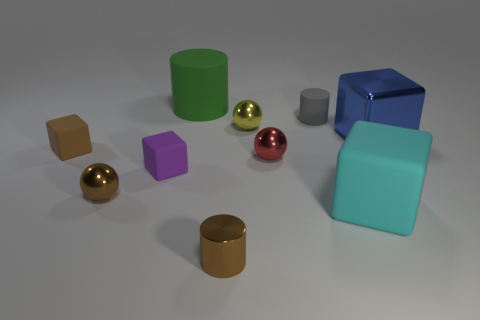Are there any patterns or symmetries in how the objects are arranged? There doesn't seem to be a deliberate pattern in the arrangement, but there's a symmetry between the blue cube and the cyan cube-like object. They are mirrored around the central axis of the composition. 